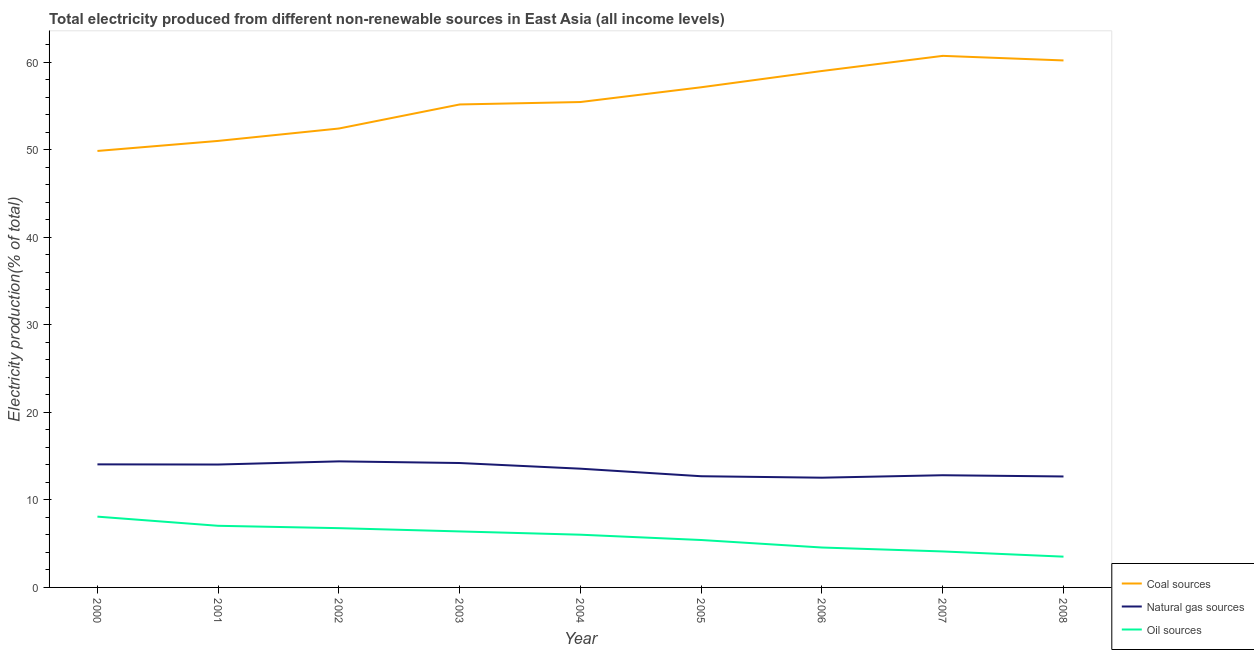Is the number of lines equal to the number of legend labels?
Keep it short and to the point. Yes. What is the percentage of electricity produced by coal in 2005?
Give a very brief answer. 57.15. Across all years, what is the maximum percentage of electricity produced by oil sources?
Your response must be concise. 8.09. Across all years, what is the minimum percentage of electricity produced by coal?
Give a very brief answer. 49.87. In which year was the percentage of electricity produced by oil sources maximum?
Offer a terse response. 2000. What is the total percentage of electricity produced by natural gas in the graph?
Offer a very short reply. 121.03. What is the difference between the percentage of electricity produced by natural gas in 2001 and that in 2007?
Give a very brief answer. 1.22. What is the difference between the percentage of electricity produced by coal in 2005 and the percentage of electricity produced by oil sources in 2001?
Your answer should be compact. 50.11. What is the average percentage of electricity produced by oil sources per year?
Give a very brief answer. 5.77. In the year 2004, what is the difference between the percentage of electricity produced by coal and percentage of electricity produced by natural gas?
Make the answer very short. 41.89. In how many years, is the percentage of electricity produced by natural gas greater than 58 %?
Offer a terse response. 0. What is the ratio of the percentage of electricity produced by coal in 2002 to that in 2008?
Offer a very short reply. 0.87. Is the percentage of electricity produced by oil sources in 2005 less than that in 2007?
Provide a succinct answer. No. What is the difference between the highest and the second highest percentage of electricity produced by coal?
Your answer should be very brief. 0.52. What is the difference between the highest and the lowest percentage of electricity produced by oil sources?
Your answer should be very brief. 4.57. Is the sum of the percentage of electricity produced by oil sources in 2001 and 2005 greater than the maximum percentage of electricity produced by coal across all years?
Your answer should be compact. No. Is it the case that in every year, the sum of the percentage of electricity produced by coal and percentage of electricity produced by natural gas is greater than the percentage of electricity produced by oil sources?
Ensure brevity in your answer.  Yes. Does the percentage of electricity produced by oil sources monotonically increase over the years?
Your response must be concise. No. Is the percentage of electricity produced by oil sources strictly greater than the percentage of electricity produced by natural gas over the years?
Ensure brevity in your answer.  No. Is the percentage of electricity produced by natural gas strictly less than the percentage of electricity produced by oil sources over the years?
Keep it short and to the point. No. How many lines are there?
Ensure brevity in your answer.  3. Are the values on the major ticks of Y-axis written in scientific E-notation?
Provide a short and direct response. No. Where does the legend appear in the graph?
Keep it short and to the point. Bottom right. How many legend labels are there?
Offer a very short reply. 3. What is the title of the graph?
Keep it short and to the point. Total electricity produced from different non-renewable sources in East Asia (all income levels). Does "Labor Market" appear as one of the legend labels in the graph?
Provide a short and direct response. No. What is the Electricity production(% of total) in Coal sources in 2000?
Offer a very short reply. 49.87. What is the Electricity production(% of total) of Natural gas sources in 2000?
Offer a very short reply. 14.06. What is the Electricity production(% of total) of Oil sources in 2000?
Your answer should be very brief. 8.09. What is the Electricity production(% of total) of Coal sources in 2001?
Your response must be concise. 51.02. What is the Electricity production(% of total) of Natural gas sources in 2001?
Ensure brevity in your answer.  14.04. What is the Electricity production(% of total) of Oil sources in 2001?
Your answer should be compact. 7.04. What is the Electricity production(% of total) in Coal sources in 2002?
Give a very brief answer. 52.44. What is the Electricity production(% of total) in Natural gas sources in 2002?
Your response must be concise. 14.41. What is the Electricity production(% of total) in Oil sources in 2002?
Your answer should be very brief. 6.77. What is the Electricity production(% of total) in Coal sources in 2003?
Your answer should be very brief. 55.18. What is the Electricity production(% of total) of Natural gas sources in 2003?
Your answer should be very brief. 14.21. What is the Electricity production(% of total) of Oil sources in 2003?
Provide a succinct answer. 6.4. What is the Electricity production(% of total) of Coal sources in 2004?
Your response must be concise. 55.46. What is the Electricity production(% of total) of Natural gas sources in 2004?
Your answer should be compact. 13.57. What is the Electricity production(% of total) in Oil sources in 2004?
Offer a terse response. 6.02. What is the Electricity production(% of total) of Coal sources in 2005?
Your answer should be compact. 57.15. What is the Electricity production(% of total) of Natural gas sources in 2005?
Offer a terse response. 12.7. What is the Electricity production(% of total) in Oil sources in 2005?
Keep it short and to the point. 5.42. What is the Electricity production(% of total) in Coal sources in 2006?
Your response must be concise. 59.01. What is the Electricity production(% of total) in Natural gas sources in 2006?
Offer a terse response. 12.54. What is the Electricity production(% of total) in Oil sources in 2006?
Keep it short and to the point. 4.56. What is the Electricity production(% of total) of Coal sources in 2007?
Give a very brief answer. 60.74. What is the Electricity production(% of total) in Natural gas sources in 2007?
Your response must be concise. 12.82. What is the Electricity production(% of total) of Oil sources in 2007?
Ensure brevity in your answer.  4.11. What is the Electricity production(% of total) in Coal sources in 2008?
Your response must be concise. 60.21. What is the Electricity production(% of total) in Natural gas sources in 2008?
Ensure brevity in your answer.  12.68. What is the Electricity production(% of total) in Oil sources in 2008?
Ensure brevity in your answer.  3.52. Across all years, what is the maximum Electricity production(% of total) in Coal sources?
Your answer should be very brief. 60.74. Across all years, what is the maximum Electricity production(% of total) of Natural gas sources?
Keep it short and to the point. 14.41. Across all years, what is the maximum Electricity production(% of total) of Oil sources?
Give a very brief answer. 8.09. Across all years, what is the minimum Electricity production(% of total) of Coal sources?
Your response must be concise. 49.87. Across all years, what is the minimum Electricity production(% of total) in Natural gas sources?
Make the answer very short. 12.54. Across all years, what is the minimum Electricity production(% of total) of Oil sources?
Provide a short and direct response. 3.52. What is the total Electricity production(% of total) of Coal sources in the graph?
Provide a succinct answer. 501.08. What is the total Electricity production(% of total) in Natural gas sources in the graph?
Make the answer very short. 121.03. What is the total Electricity production(% of total) of Oil sources in the graph?
Provide a short and direct response. 51.93. What is the difference between the Electricity production(% of total) in Coal sources in 2000 and that in 2001?
Provide a short and direct response. -1.15. What is the difference between the Electricity production(% of total) of Natural gas sources in 2000 and that in 2001?
Provide a succinct answer. 0.02. What is the difference between the Electricity production(% of total) in Oil sources in 2000 and that in 2001?
Provide a short and direct response. 1.05. What is the difference between the Electricity production(% of total) of Coal sources in 2000 and that in 2002?
Provide a short and direct response. -2.56. What is the difference between the Electricity production(% of total) in Natural gas sources in 2000 and that in 2002?
Provide a succinct answer. -0.34. What is the difference between the Electricity production(% of total) of Oil sources in 2000 and that in 2002?
Offer a terse response. 1.32. What is the difference between the Electricity production(% of total) of Coal sources in 2000 and that in 2003?
Keep it short and to the point. -5.31. What is the difference between the Electricity production(% of total) of Natural gas sources in 2000 and that in 2003?
Give a very brief answer. -0.15. What is the difference between the Electricity production(% of total) of Oil sources in 2000 and that in 2003?
Offer a terse response. 1.69. What is the difference between the Electricity production(% of total) of Coal sources in 2000 and that in 2004?
Make the answer very short. -5.59. What is the difference between the Electricity production(% of total) of Natural gas sources in 2000 and that in 2004?
Offer a terse response. 0.49. What is the difference between the Electricity production(% of total) in Oil sources in 2000 and that in 2004?
Your answer should be very brief. 2.06. What is the difference between the Electricity production(% of total) in Coal sources in 2000 and that in 2005?
Provide a short and direct response. -7.28. What is the difference between the Electricity production(% of total) in Natural gas sources in 2000 and that in 2005?
Provide a succinct answer. 1.36. What is the difference between the Electricity production(% of total) in Oil sources in 2000 and that in 2005?
Keep it short and to the point. 2.67. What is the difference between the Electricity production(% of total) of Coal sources in 2000 and that in 2006?
Give a very brief answer. -9.14. What is the difference between the Electricity production(% of total) of Natural gas sources in 2000 and that in 2006?
Offer a terse response. 1.52. What is the difference between the Electricity production(% of total) in Oil sources in 2000 and that in 2006?
Your response must be concise. 3.53. What is the difference between the Electricity production(% of total) in Coal sources in 2000 and that in 2007?
Your answer should be compact. -10.86. What is the difference between the Electricity production(% of total) of Natural gas sources in 2000 and that in 2007?
Give a very brief answer. 1.24. What is the difference between the Electricity production(% of total) of Oil sources in 2000 and that in 2007?
Offer a terse response. 3.97. What is the difference between the Electricity production(% of total) in Coal sources in 2000 and that in 2008?
Keep it short and to the point. -10.34. What is the difference between the Electricity production(% of total) in Natural gas sources in 2000 and that in 2008?
Make the answer very short. 1.38. What is the difference between the Electricity production(% of total) in Oil sources in 2000 and that in 2008?
Make the answer very short. 4.57. What is the difference between the Electricity production(% of total) in Coal sources in 2001 and that in 2002?
Provide a succinct answer. -1.42. What is the difference between the Electricity production(% of total) of Natural gas sources in 2001 and that in 2002?
Offer a terse response. -0.36. What is the difference between the Electricity production(% of total) of Oil sources in 2001 and that in 2002?
Keep it short and to the point. 0.27. What is the difference between the Electricity production(% of total) of Coal sources in 2001 and that in 2003?
Keep it short and to the point. -4.16. What is the difference between the Electricity production(% of total) of Natural gas sources in 2001 and that in 2003?
Provide a succinct answer. -0.17. What is the difference between the Electricity production(% of total) in Oil sources in 2001 and that in 2003?
Provide a succinct answer. 0.64. What is the difference between the Electricity production(% of total) in Coal sources in 2001 and that in 2004?
Provide a succinct answer. -4.44. What is the difference between the Electricity production(% of total) in Natural gas sources in 2001 and that in 2004?
Offer a very short reply. 0.47. What is the difference between the Electricity production(% of total) of Oil sources in 2001 and that in 2004?
Your response must be concise. 1.02. What is the difference between the Electricity production(% of total) of Coal sources in 2001 and that in 2005?
Make the answer very short. -6.13. What is the difference between the Electricity production(% of total) of Natural gas sources in 2001 and that in 2005?
Your answer should be very brief. 1.34. What is the difference between the Electricity production(% of total) in Oil sources in 2001 and that in 2005?
Make the answer very short. 1.62. What is the difference between the Electricity production(% of total) of Coal sources in 2001 and that in 2006?
Ensure brevity in your answer.  -7.99. What is the difference between the Electricity production(% of total) of Natural gas sources in 2001 and that in 2006?
Offer a very short reply. 1.5. What is the difference between the Electricity production(% of total) of Oil sources in 2001 and that in 2006?
Your answer should be very brief. 2.48. What is the difference between the Electricity production(% of total) in Coal sources in 2001 and that in 2007?
Offer a very short reply. -9.72. What is the difference between the Electricity production(% of total) of Natural gas sources in 2001 and that in 2007?
Your answer should be compact. 1.22. What is the difference between the Electricity production(% of total) in Oil sources in 2001 and that in 2007?
Make the answer very short. 2.93. What is the difference between the Electricity production(% of total) in Coal sources in 2001 and that in 2008?
Your answer should be compact. -9.19. What is the difference between the Electricity production(% of total) of Natural gas sources in 2001 and that in 2008?
Ensure brevity in your answer.  1.36. What is the difference between the Electricity production(% of total) of Oil sources in 2001 and that in 2008?
Your answer should be compact. 3.52. What is the difference between the Electricity production(% of total) in Coal sources in 2002 and that in 2003?
Your answer should be compact. -2.75. What is the difference between the Electricity production(% of total) of Natural gas sources in 2002 and that in 2003?
Your answer should be very brief. 0.19. What is the difference between the Electricity production(% of total) in Oil sources in 2002 and that in 2003?
Give a very brief answer. 0.37. What is the difference between the Electricity production(% of total) in Coal sources in 2002 and that in 2004?
Your answer should be very brief. -3.03. What is the difference between the Electricity production(% of total) in Natural gas sources in 2002 and that in 2004?
Ensure brevity in your answer.  0.84. What is the difference between the Electricity production(% of total) in Oil sources in 2002 and that in 2004?
Your answer should be very brief. 0.75. What is the difference between the Electricity production(% of total) of Coal sources in 2002 and that in 2005?
Keep it short and to the point. -4.71. What is the difference between the Electricity production(% of total) in Natural gas sources in 2002 and that in 2005?
Keep it short and to the point. 1.7. What is the difference between the Electricity production(% of total) of Oil sources in 2002 and that in 2005?
Make the answer very short. 1.35. What is the difference between the Electricity production(% of total) of Coal sources in 2002 and that in 2006?
Provide a succinct answer. -6.57. What is the difference between the Electricity production(% of total) in Natural gas sources in 2002 and that in 2006?
Your answer should be compact. 1.87. What is the difference between the Electricity production(% of total) of Oil sources in 2002 and that in 2006?
Your answer should be compact. 2.21. What is the difference between the Electricity production(% of total) of Coal sources in 2002 and that in 2007?
Provide a succinct answer. -8.3. What is the difference between the Electricity production(% of total) of Natural gas sources in 2002 and that in 2007?
Keep it short and to the point. 1.59. What is the difference between the Electricity production(% of total) in Oil sources in 2002 and that in 2007?
Provide a succinct answer. 2.66. What is the difference between the Electricity production(% of total) of Coal sources in 2002 and that in 2008?
Make the answer very short. -7.78. What is the difference between the Electricity production(% of total) of Natural gas sources in 2002 and that in 2008?
Provide a short and direct response. 1.73. What is the difference between the Electricity production(% of total) of Oil sources in 2002 and that in 2008?
Your answer should be compact. 3.26. What is the difference between the Electricity production(% of total) in Coal sources in 2003 and that in 2004?
Offer a very short reply. -0.28. What is the difference between the Electricity production(% of total) of Natural gas sources in 2003 and that in 2004?
Offer a very short reply. 0.65. What is the difference between the Electricity production(% of total) in Oil sources in 2003 and that in 2004?
Provide a short and direct response. 0.37. What is the difference between the Electricity production(% of total) of Coal sources in 2003 and that in 2005?
Give a very brief answer. -1.97. What is the difference between the Electricity production(% of total) of Natural gas sources in 2003 and that in 2005?
Keep it short and to the point. 1.51. What is the difference between the Electricity production(% of total) of Oil sources in 2003 and that in 2005?
Your answer should be compact. 0.98. What is the difference between the Electricity production(% of total) of Coal sources in 2003 and that in 2006?
Keep it short and to the point. -3.82. What is the difference between the Electricity production(% of total) of Natural gas sources in 2003 and that in 2006?
Keep it short and to the point. 1.67. What is the difference between the Electricity production(% of total) in Oil sources in 2003 and that in 2006?
Give a very brief answer. 1.84. What is the difference between the Electricity production(% of total) of Coal sources in 2003 and that in 2007?
Offer a very short reply. -5.55. What is the difference between the Electricity production(% of total) in Natural gas sources in 2003 and that in 2007?
Provide a short and direct response. 1.39. What is the difference between the Electricity production(% of total) in Oil sources in 2003 and that in 2007?
Offer a very short reply. 2.29. What is the difference between the Electricity production(% of total) of Coal sources in 2003 and that in 2008?
Give a very brief answer. -5.03. What is the difference between the Electricity production(% of total) in Natural gas sources in 2003 and that in 2008?
Your response must be concise. 1.54. What is the difference between the Electricity production(% of total) of Oil sources in 2003 and that in 2008?
Provide a short and direct response. 2.88. What is the difference between the Electricity production(% of total) in Coal sources in 2004 and that in 2005?
Provide a short and direct response. -1.69. What is the difference between the Electricity production(% of total) in Natural gas sources in 2004 and that in 2005?
Provide a succinct answer. 0.86. What is the difference between the Electricity production(% of total) in Oil sources in 2004 and that in 2005?
Your response must be concise. 0.61. What is the difference between the Electricity production(% of total) of Coal sources in 2004 and that in 2006?
Ensure brevity in your answer.  -3.55. What is the difference between the Electricity production(% of total) of Natural gas sources in 2004 and that in 2006?
Provide a succinct answer. 1.03. What is the difference between the Electricity production(% of total) of Oil sources in 2004 and that in 2006?
Your answer should be compact. 1.46. What is the difference between the Electricity production(% of total) of Coal sources in 2004 and that in 2007?
Your answer should be compact. -5.27. What is the difference between the Electricity production(% of total) of Natural gas sources in 2004 and that in 2007?
Give a very brief answer. 0.75. What is the difference between the Electricity production(% of total) in Oil sources in 2004 and that in 2007?
Your answer should be very brief. 1.91. What is the difference between the Electricity production(% of total) in Coal sources in 2004 and that in 2008?
Offer a terse response. -4.75. What is the difference between the Electricity production(% of total) in Natural gas sources in 2004 and that in 2008?
Give a very brief answer. 0.89. What is the difference between the Electricity production(% of total) of Oil sources in 2004 and that in 2008?
Ensure brevity in your answer.  2.51. What is the difference between the Electricity production(% of total) in Coal sources in 2005 and that in 2006?
Give a very brief answer. -1.86. What is the difference between the Electricity production(% of total) of Natural gas sources in 2005 and that in 2006?
Ensure brevity in your answer.  0.17. What is the difference between the Electricity production(% of total) of Oil sources in 2005 and that in 2006?
Your answer should be compact. 0.86. What is the difference between the Electricity production(% of total) in Coal sources in 2005 and that in 2007?
Your answer should be compact. -3.59. What is the difference between the Electricity production(% of total) of Natural gas sources in 2005 and that in 2007?
Your response must be concise. -0.12. What is the difference between the Electricity production(% of total) in Oil sources in 2005 and that in 2007?
Your answer should be compact. 1.31. What is the difference between the Electricity production(% of total) in Coal sources in 2005 and that in 2008?
Provide a succinct answer. -3.06. What is the difference between the Electricity production(% of total) in Natural gas sources in 2005 and that in 2008?
Your answer should be very brief. 0.03. What is the difference between the Electricity production(% of total) in Oil sources in 2005 and that in 2008?
Your response must be concise. 1.9. What is the difference between the Electricity production(% of total) of Coal sources in 2006 and that in 2007?
Ensure brevity in your answer.  -1.73. What is the difference between the Electricity production(% of total) of Natural gas sources in 2006 and that in 2007?
Keep it short and to the point. -0.28. What is the difference between the Electricity production(% of total) of Oil sources in 2006 and that in 2007?
Your response must be concise. 0.45. What is the difference between the Electricity production(% of total) in Coal sources in 2006 and that in 2008?
Ensure brevity in your answer.  -1.2. What is the difference between the Electricity production(% of total) of Natural gas sources in 2006 and that in 2008?
Offer a terse response. -0.14. What is the difference between the Electricity production(% of total) of Oil sources in 2006 and that in 2008?
Your answer should be compact. 1.04. What is the difference between the Electricity production(% of total) of Coal sources in 2007 and that in 2008?
Offer a very short reply. 0.52. What is the difference between the Electricity production(% of total) of Natural gas sources in 2007 and that in 2008?
Offer a very short reply. 0.14. What is the difference between the Electricity production(% of total) of Oil sources in 2007 and that in 2008?
Offer a very short reply. 0.6. What is the difference between the Electricity production(% of total) of Coal sources in 2000 and the Electricity production(% of total) of Natural gas sources in 2001?
Offer a terse response. 35.83. What is the difference between the Electricity production(% of total) of Coal sources in 2000 and the Electricity production(% of total) of Oil sources in 2001?
Provide a succinct answer. 42.83. What is the difference between the Electricity production(% of total) of Natural gas sources in 2000 and the Electricity production(% of total) of Oil sources in 2001?
Make the answer very short. 7.02. What is the difference between the Electricity production(% of total) of Coal sources in 2000 and the Electricity production(% of total) of Natural gas sources in 2002?
Your answer should be compact. 35.47. What is the difference between the Electricity production(% of total) in Coal sources in 2000 and the Electricity production(% of total) in Oil sources in 2002?
Provide a succinct answer. 43.1. What is the difference between the Electricity production(% of total) in Natural gas sources in 2000 and the Electricity production(% of total) in Oil sources in 2002?
Provide a succinct answer. 7.29. What is the difference between the Electricity production(% of total) of Coal sources in 2000 and the Electricity production(% of total) of Natural gas sources in 2003?
Keep it short and to the point. 35.66. What is the difference between the Electricity production(% of total) of Coal sources in 2000 and the Electricity production(% of total) of Oil sources in 2003?
Ensure brevity in your answer.  43.47. What is the difference between the Electricity production(% of total) in Natural gas sources in 2000 and the Electricity production(% of total) in Oil sources in 2003?
Your answer should be very brief. 7.66. What is the difference between the Electricity production(% of total) of Coal sources in 2000 and the Electricity production(% of total) of Natural gas sources in 2004?
Keep it short and to the point. 36.3. What is the difference between the Electricity production(% of total) of Coal sources in 2000 and the Electricity production(% of total) of Oil sources in 2004?
Keep it short and to the point. 43.85. What is the difference between the Electricity production(% of total) of Natural gas sources in 2000 and the Electricity production(% of total) of Oil sources in 2004?
Offer a terse response. 8.04. What is the difference between the Electricity production(% of total) in Coal sources in 2000 and the Electricity production(% of total) in Natural gas sources in 2005?
Offer a terse response. 37.17. What is the difference between the Electricity production(% of total) of Coal sources in 2000 and the Electricity production(% of total) of Oil sources in 2005?
Your answer should be compact. 44.45. What is the difference between the Electricity production(% of total) of Natural gas sources in 2000 and the Electricity production(% of total) of Oil sources in 2005?
Your answer should be very brief. 8.64. What is the difference between the Electricity production(% of total) in Coal sources in 2000 and the Electricity production(% of total) in Natural gas sources in 2006?
Make the answer very short. 37.33. What is the difference between the Electricity production(% of total) in Coal sources in 2000 and the Electricity production(% of total) in Oil sources in 2006?
Provide a short and direct response. 45.31. What is the difference between the Electricity production(% of total) in Natural gas sources in 2000 and the Electricity production(% of total) in Oil sources in 2006?
Your response must be concise. 9.5. What is the difference between the Electricity production(% of total) in Coal sources in 2000 and the Electricity production(% of total) in Natural gas sources in 2007?
Your answer should be compact. 37.05. What is the difference between the Electricity production(% of total) of Coal sources in 2000 and the Electricity production(% of total) of Oil sources in 2007?
Your response must be concise. 45.76. What is the difference between the Electricity production(% of total) of Natural gas sources in 2000 and the Electricity production(% of total) of Oil sources in 2007?
Your answer should be compact. 9.95. What is the difference between the Electricity production(% of total) of Coal sources in 2000 and the Electricity production(% of total) of Natural gas sources in 2008?
Keep it short and to the point. 37.19. What is the difference between the Electricity production(% of total) in Coal sources in 2000 and the Electricity production(% of total) in Oil sources in 2008?
Keep it short and to the point. 46.35. What is the difference between the Electricity production(% of total) of Natural gas sources in 2000 and the Electricity production(% of total) of Oil sources in 2008?
Offer a very short reply. 10.54. What is the difference between the Electricity production(% of total) in Coal sources in 2001 and the Electricity production(% of total) in Natural gas sources in 2002?
Offer a very short reply. 36.61. What is the difference between the Electricity production(% of total) of Coal sources in 2001 and the Electricity production(% of total) of Oil sources in 2002?
Provide a short and direct response. 44.25. What is the difference between the Electricity production(% of total) in Natural gas sources in 2001 and the Electricity production(% of total) in Oil sources in 2002?
Offer a very short reply. 7.27. What is the difference between the Electricity production(% of total) of Coal sources in 2001 and the Electricity production(% of total) of Natural gas sources in 2003?
Provide a succinct answer. 36.81. What is the difference between the Electricity production(% of total) of Coal sources in 2001 and the Electricity production(% of total) of Oil sources in 2003?
Keep it short and to the point. 44.62. What is the difference between the Electricity production(% of total) of Natural gas sources in 2001 and the Electricity production(% of total) of Oil sources in 2003?
Make the answer very short. 7.64. What is the difference between the Electricity production(% of total) of Coal sources in 2001 and the Electricity production(% of total) of Natural gas sources in 2004?
Provide a succinct answer. 37.45. What is the difference between the Electricity production(% of total) in Coal sources in 2001 and the Electricity production(% of total) in Oil sources in 2004?
Offer a terse response. 45. What is the difference between the Electricity production(% of total) of Natural gas sources in 2001 and the Electricity production(% of total) of Oil sources in 2004?
Make the answer very short. 8.02. What is the difference between the Electricity production(% of total) of Coal sources in 2001 and the Electricity production(% of total) of Natural gas sources in 2005?
Your response must be concise. 38.32. What is the difference between the Electricity production(% of total) of Coal sources in 2001 and the Electricity production(% of total) of Oil sources in 2005?
Offer a terse response. 45.6. What is the difference between the Electricity production(% of total) in Natural gas sources in 2001 and the Electricity production(% of total) in Oil sources in 2005?
Provide a short and direct response. 8.62. What is the difference between the Electricity production(% of total) in Coal sources in 2001 and the Electricity production(% of total) in Natural gas sources in 2006?
Ensure brevity in your answer.  38.48. What is the difference between the Electricity production(% of total) in Coal sources in 2001 and the Electricity production(% of total) in Oil sources in 2006?
Give a very brief answer. 46.46. What is the difference between the Electricity production(% of total) in Natural gas sources in 2001 and the Electricity production(% of total) in Oil sources in 2006?
Your response must be concise. 9.48. What is the difference between the Electricity production(% of total) of Coal sources in 2001 and the Electricity production(% of total) of Natural gas sources in 2007?
Make the answer very short. 38.2. What is the difference between the Electricity production(% of total) of Coal sources in 2001 and the Electricity production(% of total) of Oil sources in 2007?
Offer a terse response. 46.91. What is the difference between the Electricity production(% of total) in Natural gas sources in 2001 and the Electricity production(% of total) in Oil sources in 2007?
Give a very brief answer. 9.93. What is the difference between the Electricity production(% of total) of Coal sources in 2001 and the Electricity production(% of total) of Natural gas sources in 2008?
Your answer should be compact. 38.34. What is the difference between the Electricity production(% of total) in Coal sources in 2001 and the Electricity production(% of total) in Oil sources in 2008?
Make the answer very short. 47.5. What is the difference between the Electricity production(% of total) of Natural gas sources in 2001 and the Electricity production(% of total) of Oil sources in 2008?
Give a very brief answer. 10.52. What is the difference between the Electricity production(% of total) in Coal sources in 2002 and the Electricity production(% of total) in Natural gas sources in 2003?
Provide a succinct answer. 38.22. What is the difference between the Electricity production(% of total) in Coal sources in 2002 and the Electricity production(% of total) in Oil sources in 2003?
Your answer should be compact. 46.04. What is the difference between the Electricity production(% of total) of Natural gas sources in 2002 and the Electricity production(% of total) of Oil sources in 2003?
Your response must be concise. 8.01. What is the difference between the Electricity production(% of total) in Coal sources in 2002 and the Electricity production(% of total) in Natural gas sources in 2004?
Keep it short and to the point. 38.87. What is the difference between the Electricity production(% of total) in Coal sources in 2002 and the Electricity production(% of total) in Oil sources in 2004?
Your response must be concise. 46.41. What is the difference between the Electricity production(% of total) of Natural gas sources in 2002 and the Electricity production(% of total) of Oil sources in 2004?
Keep it short and to the point. 8.38. What is the difference between the Electricity production(% of total) in Coal sources in 2002 and the Electricity production(% of total) in Natural gas sources in 2005?
Provide a short and direct response. 39.73. What is the difference between the Electricity production(% of total) of Coal sources in 2002 and the Electricity production(% of total) of Oil sources in 2005?
Your response must be concise. 47.02. What is the difference between the Electricity production(% of total) in Natural gas sources in 2002 and the Electricity production(% of total) in Oil sources in 2005?
Your answer should be compact. 8.99. What is the difference between the Electricity production(% of total) of Coal sources in 2002 and the Electricity production(% of total) of Natural gas sources in 2006?
Ensure brevity in your answer.  39.9. What is the difference between the Electricity production(% of total) in Coal sources in 2002 and the Electricity production(% of total) in Oil sources in 2006?
Give a very brief answer. 47.88. What is the difference between the Electricity production(% of total) of Natural gas sources in 2002 and the Electricity production(% of total) of Oil sources in 2006?
Your response must be concise. 9.84. What is the difference between the Electricity production(% of total) of Coal sources in 2002 and the Electricity production(% of total) of Natural gas sources in 2007?
Offer a terse response. 39.62. What is the difference between the Electricity production(% of total) of Coal sources in 2002 and the Electricity production(% of total) of Oil sources in 2007?
Offer a terse response. 48.32. What is the difference between the Electricity production(% of total) of Natural gas sources in 2002 and the Electricity production(% of total) of Oil sources in 2007?
Make the answer very short. 10.29. What is the difference between the Electricity production(% of total) in Coal sources in 2002 and the Electricity production(% of total) in Natural gas sources in 2008?
Make the answer very short. 39.76. What is the difference between the Electricity production(% of total) in Coal sources in 2002 and the Electricity production(% of total) in Oil sources in 2008?
Provide a succinct answer. 48.92. What is the difference between the Electricity production(% of total) of Natural gas sources in 2002 and the Electricity production(% of total) of Oil sources in 2008?
Your answer should be compact. 10.89. What is the difference between the Electricity production(% of total) of Coal sources in 2003 and the Electricity production(% of total) of Natural gas sources in 2004?
Make the answer very short. 41.62. What is the difference between the Electricity production(% of total) in Coal sources in 2003 and the Electricity production(% of total) in Oil sources in 2004?
Offer a very short reply. 49.16. What is the difference between the Electricity production(% of total) in Natural gas sources in 2003 and the Electricity production(% of total) in Oil sources in 2004?
Provide a short and direct response. 8.19. What is the difference between the Electricity production(% of total) in Coal sources in 2003 and the Electricity production(% of total) in Natural gas sources in 2005?
Your answer should be compact. 42.48. What is the difference between the Electricity production(% of total) in Coal sources in 2003 and the Electricity production(% of total) in Oil sources in 2005?
Make the answer very short. 49.77. What is the difference between the Electricity production(% of total) in Natural gas sources in 2003 and the Electricity production(% of total) in Oil sources in 2005?
Offer a terse response. 8.8. What is the difference between the Electricity production(% of total) of Coal sources in 2003 and the Electricity production(% of total) of Natural gas sources in 2006?
Your answer should be compact. 42.64. What is the difference between the Electricity production(% of total) in Coal sources in 2003 and the Electricity production(% of total) in Oil sources in 2006?
Offer a very short reply. 50.62. What is the difference between the Electricity production(% of total) of Natural gas sources in 2003 and the Electricity production(% of total) of Oil sources in 2006?
Your answer should be compact. 9.65. What is the difference between the Electricity production(% of total) in Coal sources in 2003 and the Electricity production(% of total) in Natural gas sources in 2007?
Ensure brevity in your answer.  42.36. What is the difference between the Electricity production(% of total) of Coal sources in 2003 and the Electricity production(% of total) of Oil sources in 2007?
Your answer should be compact. 51.07. What is the difference between the Electricity production(% of total) in Natural gas sources in 2003 and the Electricity production(% of total) in Oil sources in 2007?
Your answer should be very brief. 10.1. What is the difference between the Electricity production(% of total) in Coal sources in 2003 and the Electricity production(% of total) in Natural gas sources in 2008?
Give a very brief answer. 42.51. What is the difference between the Electricity production(% of total) of Coal sources in 2003 and the Electricity production(% of total) of Oil sources in 2008?
Your response must be concise. 51.67. What is the difference between the Electricity production(% of total) of Natural gas sources in 2003 and the Electricity production(% of total) of Oil sources in 2008?
Offer a terse response. 10.7. What is the difference between the Electricity production(% of total) of Coal sources in 2004 and the Electricity production(% of total) of Natural gas sources in 2005?
Provide a short and direct response. 42.76. What is the difference between the Electricity production(% of total) in Coal sources in 2004 and the Electricity production(% of total) in Oil sources in 2005?
Offer a very short reply. 50.04. What is the difference between the Electricity production(% of total) of Natural gas sources in 2004 and the Electricity production(% of total) of Oil sources in 2005?
Ensure brevity in your answer.  8.15. What is the difference between the Electricity production(% of total) of Coal sources in 2004 and the Electricity production(% of total) of Natural gas sources in 2006?
Offer a very short reply. 42.92. What is the difference between the Electricity production(% of total) of Coal sources in 2004 and the Electricity production(% of total) of Oil sources in 2006?
Your answer should be compact. 50.9. What is the difference between the Electricity production(% of total) in Natural gas sources in 2004 and the Electricity production(% of total) in Oil sources in 2006?
Provide a short and direct response. 9.01. What is the difference between the Electricity production(% of total) of Coal sources in 2004 and the Electricity production(% of total) of Natural gas sources in 2007?
Keep it short and to the point. 42.64. What is the difference between the Electricity production(% of total) of Coal sources in 2004 and the Electricity production(% of total) of Oil sources in 2007?
Keep it short and to the point. 51.35. What is the difference between the Electricity production(% of total) of Natural gas sources in 2004 and the Electricity production(% of total) of Oil sources in 2007?
Your answer should be very brief. 9.45. What is the difference between the Electricity production(% of total) of Coal sources in 2004 and the Electricity production(% of total) of Natural gas sources in 2008?
Your answer should be very brief. 42.78. What is the difference between the Electricity production(% of total) of Coal sources in 2004 and the Electricity production(% of total) of Oil sources in 2008?
Provide a short and direct response. 51.95. What is the difference between the Electricity production(% of total) of Natural gas sources in 2004 and the Electricity production(% of total) of Oil sources in 2008?
Provide a short and direct response. 10.05. What is the difference between the Electricity production(% of total) of Coal sources in 2005 and the Electricity production(% of total) of Natural gas sources in 2006?
Provide a short and direct response. 44.61. What is the difference between the Electricity production(% of total) of Coal sources in 2005 and the Electricity production(% of total) of Oil sources in 2006?
Make the answer very short. 52.59. What is the difference between the Electricity production(% of total) of Natural gas sources in 2005 and the Electricity production(% of total) of Oil sources in 2006?
Make the answer very short. 8.14. What is the difference between the Electricity production(% of total) of Coal sources in 2005 and the Electricity production(% of total) of Natural gas sources in 2007?
Make the answer very short. 44.33. What is the difference between the Electricity production(% of total) of Coal sources in 2005 and the Electricity production(% of total) of Oil sources in 2007?
Your answer should be compact. 53.04. What is the difference between the Electricity production(% of total) of Natural gas sources in 2005 and the Electricity production(% of total) of Oil sources in 2007?
Offer a terse response. 8.59. What is the difference between the Electricity production(% of total) of Coal sources in 2005 and the Electricity production(% of total) of Natural gas sources in 2008?
Provide a short and direct response. 44.47. What is the difference between the Electricity production(% of total) of Coal sources in 2005 and the Electricity production(% of total) of Oil sources in 2008?
Give a very brief answer. 53.63. What is the difference between the Electricity production(% of total) of Natural gas sources in 2005 and the Electricity production(% of total) of Oil sources in 2008?
Your answer should be compact. 9.19. What is the difference between the Electricity production(% of total) in Coal sources in 2006 and the Electricity production(% of total) in Natural gas sources in 2007?
Your response must be concise. 46.19. What is the difference between the Electricity production(% of total) of Coal sources in 2006 and the Electricity production(% of total) of Oil sources in 2007?
Provide a short and direct response. 54.9. What is the difference between the Electricity production(% of total) in Natural gas sources in 2006 and the Electricity production(% of total) in Oil sources in 2007?
Your answer should be compact. 8.43. What is the difference between the Electricity production(% of total) of Coal sources in 2006 and the Electricity production(% of total) of Natural gas sources in 2008?
Keep it short and to the point. 46.33. What is the difference between the Electricity production(% of total) of Coal sources in 2006 and the Electricity production(% of total) of Oil sources in 2008?
Offer a terse response. 55.49. What is the difference between the Electricity production(% of total) of Natural gas sources in 2006 and the Electricity production(% of total) of Oil sources in 2008?
Offer a terse response. 9.02. What is the difference between the Electricity production(% of total) of Coal sources in 2007 and the Electricity production(% of total) of Natural gas sources in 2008?
Offer a very short reply. 48.06. What is the difference between the Electricity production(% of total) of Coal sources in 2007 and the Electricity production(% of total) of Oil sources in 2008?
Give a very brief answer. 57.22. What is the difference between the Electricity production(% of total) in Natural gas sources in 2007 and the Electricity production(% of total) in Oil sources in 2008?
Make the answer very short. 9.3. What is the average Electricity production(% of total) in Coal sources per year?
Provide a short and direct response. 55.68. What is the average Electricity production(% of total) in Natural gas sources per year?
Give a very brief answer. 13.45. What is the average Electricity production(% of total) in Oil sources per year?
Provide a succinct answer. 5.77. In the year 2000, what is the difference between the Electricity production(% of total) of Coal sources and Electricity production(% of total) of Natural gas sources?
Ensure brevity in your answer.  35.81. In the year 2000, what is the difference between the Electricity production(% of total) of Coal sources and Electricity production(% of total) of Oil sources?
Offer a very short reply. 41.78. In the year 2000, what is the difference between the Electricity production(% of total) of Natural gas sources and Electricity production(% of total) of Oil sources?
Provide a succinct answer. 5.97. In the year 2001, what is the difference between the Electricity production(% of total) of Coal sources and Electricity production(% of total) of Natural gas sources?
Ensure brevity in your answer.  36.98. In the year 2001, what is the difference between the Electricity production(% of total) in Coal sources and Electricity production(% of total) in Oil sources?
Offer a terse response. 43.98. In the year 2001, what is the difference between the Electricity production(% of total) of Natural gas sources and Electricity production(% of total) of Oil sources?
Your response must be concise. 7. In the year 2002, what is the difference between the Electricity production(% of total) in Coal sources and Electricity production(% of total) in Natural gas sources?
Make the answer very short. 38.03. In the year 2002, what is the difference between the Electricity production(% of total) in Coal sources and Electricity production(% of total) in Oil sources?
Your answer should be compact. 45.66. In the year 2002, what is the difference between the Electricity production(% of total) of Natural gas sources and Electricity production(% of total) of Oil sources?
Give a very brief answer. 7.63. In the year 2003, what is the difference between the Electricity production(% of total) of Coal sources and Electricity production(% of total) of Natural gas sources?
Give a very brief answer. 40.97. In the year 2003, what is the difference between the Electricity production(% of total) in Coal sources and Electricity production(% of total) in Oil sources?
Offer a very short reply. 48.79. In the year 2003, what is the difference between the Electricity production(% of total) in Natural gas sources and Electricity production(% of total) in Oil sources?
Keep it short and to the point. 7.82. In the year 2004, what is the difference between the Electricity production(% of total) of Coal sources and Electricity production(% of total) of Natural gas sources?
Offer a terse response. 41.89. In the year 2004, what is the difference between the Electricity production(% of total) of Coal sources and Electricity production(% of total) of Oil sources?
Your answer should be very brief. 49.44. In the year 2004, what is the difference between the Electricity production(% of total) of Natural gas sources and Electricity production(% of total) of Oil sources?
Your answer should be very brief. 7.54. In the year 2005, what is the difference between the Electricity production(% of total) of Coal sources and Electricity production(% of total) of Natural gas sources?
Provide a succinct answer. 44.44. In the year 2005, what is the difference between the Electricity production(% of total) of Coal sources and Electricity production(% of total) of Oil sources?
Offer a very short reply. 51.73. In the year 2005, what is the difference between the Electricity production(% of total) in Natural gas sources and Electricity production(% of total) in Oil sources?
Provide a short and direct response. 7.29. In the year 2006, what is the difference between the Electricity production(% of total) in Coal sources and Electricity production(% of total) in Natural gas sources?
Your answer should be very brief. 46.47. In the year 2006, what is the difference between the Electricity production(% of total) in Coal sources and Electricity production(% of total) in Oil sources?
Give a very brief answer. 54.45. In the year 2006, what is the difference between the Electricity production(% of total) in Natural gas sources and Electricity production(% of total) in Oil sources?
Provide a short and direct response. 7.98. In the year 2007, what is the difference between the Electricity production(% of total) of Coal sources and Electricity production(% of total) of Natural gas sources?
Keep it short and to the point. 47.92. In the year 2007, what is the difference between the Electricity production(% of total) of Coal sources and Electricity production(% of total) of Oil sources?
Offer a very short reply. 56.62. In the year 2007, what is the difference between the Electricity production(% of total) of Natural gas sources and Electricity production(% of total) of Oil sources?
Your answer should be very brief. 8.71. In the year 2008, what is the difference between the Electricity production(% of total) of Coal sources and Electricity production(% of total) of Natural gas sources?
Offer a very short reply. 47.54. In the year 2008, what is the difference between the Electricity production(% of total) in Coal sources and Electricity production(% of total) in Oil sources?
Offer a very short reply. 56.7. In the year 2008, what is the difference between the Electricity production(% of total) in Natural gas sources and Electricity production(% of total) in Oil sources?
Make the answer very short. 9.16. What is the ratio of the Electricity production(% of total) in Coal sources in 2000 to that in 2001?
Keep it short and to the point. 0.98. What is the ratio of the Electricity production(% of total) in Oil sources in 2000 to that in 2001?
Provide a short and direct response. 1.15. What is the ratio of the Electricity production(% of total) in Coal sources in 2000 to that in 2002?
Your response must be concise. 0.95. What is the ratio of the Electricity production(% of total) in Natural gas sources in 2000 to that in 2002?
Your answer should be very brief. 0.98. What is the ratio of the Electricity production(% of total) in Oil sources in 2000 to that in 2002?
Offer a terse response. 1.19. What is the ratio of the Electricity production(% of total) in Coal sources in 2000 to that in 2003?
Ensure brevity in your answer.  0.9. What is the ratio of the Electricity production(% of total) in Oil sources in 2000 to that in 2003?
Make the answer very short. 1.26. What is the ratio of the Electricity production(% of total) of Coal sources in 2000 to that in 2004?
Offer a terse response. 0.9. What is the ratio of the Electricity production(% of total) of Natural gas sources in 2000 to that in 2004?
Provide a short and direct response. 1.04. What is the ratio of the Electricity production(% of total) of Oil sources in 2000 to that in 2004?
Provide a succinct answer. 1.34. What is the ratio of the Electricity production(% of total) in Coal sources in 2000 to that in 2005?
Offer a very short reply. 0.87. What is the ratio of the Electricity production(% of total) of Natural gas sources in 2000 to that in 2005?
Offer a very short reply. 1.11. What is the ratio of the Electricity production(% of total) of Oil sources in 2000 to that in 2005?
Offer a terse response. 1.49. What is the ratio of the Electricity production(% of total) in Coal sources in 2000 to that in 2006?
Ensure brevity in your answer.  0.85. What is the ratio of the Electricity production(% of total) of Natural gas sources in 2000 to that in 2006?
Make the answer very short. 1.12. What is the ratio of the Electricity production(% of total) of Oil sources in 2000 to that in 2006?
Make the answer very short. 1.77. What is the ratio of the Electricity production(% of total) in Coal sources in 2000 to that in 2007?
Ensure brevity in your answer.  0.82. What is the ratio of the Electricity production(% of total) in Natural gas sources in 2000 to that in 2007?
Provide a short and direct response. 1.1. What is the ratio of the Electricity production(% of total) in Oil sources in 2000 to that in 2007?
Your answer should be compact. 1.97. What is the ratio of the Electricity production(% of total) in Coal sources in 2000 to that in 2008?
Make the answer very short. 0.83. What is the ratio of the Electricity production(% of total) in Natural gas sources in 2000 to that in 2008?
Ensure brevity in your answer.  1.11. What is the ratio of the Electricity production(% of total) in Oil sources in 2000 to that in 2008?
Offer a very short reply. 2.3. What is the ratio of the Electricity production(% of total) of Natural gas sources in 2001 to that in 2002?
Provide a short and direct response. 0.97. What is the ratio of the Electricity production(% of total) in Oil sources in 2001 to that in 2002?
Your response must be concise. 1.04. What is the ratio of the Electricity production(% of total) in Coal sources in 2001 to that in 2003?
Your answer should be very brief. 0.92. What is the ratio of the Electricity production(% of total) in Natural gas sources in 2001 to that in 2003?
Give a very brief answer. 0.99. What is the ratio of the Electricity production(% of total) of Oil sources in 2001 to that in 2003?
Offer a terse response. 1.1. What is the ratio of the Electricity production(% of total) of Coal sources in 2001 to that in 2004?
Offer a very short reply. 0.92. What is the ratio of the Electricity production(% of total) of Natural gas sources in 2001 to that in 2004?
Make the answer very short. 1.03. What is the ratio of the Electricity production(% of total) in Oil sources in 2001 to that in 2004?
Provide a succinct answer. 1.17. What is the ratio of the Electricity production(% of total) in Coal sources in 2001 to that in 2005?
Offer a very short reply. 0.89. What is the ratio of the Electricity production(% of total) in Natural gas sources in 2001 to that in 2005?
Give a very brief answer. 1.11. What is the ratio of the Electricity production(% of total) in Oil sources in 2001 to that in 2005?
Your answer should be compact. 1.3. What is the ratio of the Electricity production(% of total) in Coal sources in 2001 to that in 2006?
Make the answer very short. 0.86. What is the ratio of the Electricity production(% of total) of Natural gas sources in 2001 to that in 2006?
Your answer should be compact. 1.12. What is the ratio of the Electricity production(% of total) of Oil sources in 2001 to that in 2006?
Offer a terse response. 1.54. What is the ratio of the Electricity production(% of total) in Coal sources in 2001 to that in 2007?
Provide a succinct answer. 0.84. What is the ratio of the Electricity production(% of total) in Natural gas sources in 2001 to that in 2007?
Provide a succinct answer. 1.1. What is the ratio of the Electricity production(% of total) in Oil sources in 2001 to that in 2007?
Keep it short and to the point. 1.71. What is the ratio of the Electricity production(% of total) of Coal sources in 2001 to that in 2008?
Provide a short and direct response. 0.85. What is the ratio of the Electricity production(% of total) in Natural gas sources in 2001 to that in 2008?
Make the answer very short. 1.11. What is the ratio of the Electricity production(% of total) of Oil sources in 2001 to that in 2008?
Provide a short and direct response. 2. What is the ratio of the Electricity production(% of total) in Coal sources in 2002 to that in 2003?
Provide a succinct answer. 0.95. What is the ratio of the Electricity production(% of total) of Natural gas sources in 2002 to that in 2003?
Your answer should be very brief. 1.01. What is the ratio of the Electricity production(% of total) of Oil sources in 2002 to that in 2003?
Your answer should be compact. 1.06. What is the ratio of the Electricity production(% of total) of Coal sources in 2002 to that in 2004?
Offer a very short reply. 0.95. What is the ratio of the Electricity production(% of total) in Natural gas sources in 2002 to that in 2004?
Ensure brevity in your answer.  1.06. What is the ratio of the Electricity production(% of total) of Oil sources in 2002 to that in 2004?
Offer a very short reply. 1.12. What is the ratio of the Electricity production(% of total) in Coal sources in 2002 to that in 2005?
Give a very brief answer. 0.92. What is the ratio of the Electricity production(% of total) of Natural gas sources in 2002 to that in 2005?
Give a very brief answer. 1.13. What is the ratio of the Electricity production(% of total) of Oil sources in 2002 to that in 2005?
Keep it short and to the point. 1.25. What is the ratio of the Electricity production(% of total) of Coal sources in 2002 to that in 2006?
Keep it short and to the point. 0.89. What is the ratio of the Electricity production(% of total) of Natural gas sources in 2002 to that in 2006?
Provide a succinct answer. 1.15. What is the ratio of the Electricity production(% of total) in Oil sources in 2002 to that in 2006?
Keep it short and to the point. 1.49. What is the ratio of the Electricity production(% of total) of Coal sources in 2002 to that in 2007?
Your answer should be compact. 0.86. What is the ratio of the Electricity production(% of total) of Natural gas sources in 2002 to that in 2007?
Provide a short and direct response. 1.12. What is the ratio of the Electricity production(% of total) in Oil sources in 2002 to that in 2007?
Offer a very short reply. 1.65. What is the ratio of the Electricity production(% of total) of Coal sources in 2002 to that in 2008?
Give a very brief answer. 0.87. What is the ratio of the Electricity production(% of total) of Natural gas sources in 2002 to that in 2008?
Your response must be concise. 1.14. What is the ratio of the Electricity production(% of total) of Oil sources in 2002 to that in 2008?
Ensure brevity in your answer.  1.93. What is the ratio of the Electricity production(% of total) of Coal sources in 2003 to that in 2004?
Provide a short and direct response. 0.99. What is the ratio of the Electricity production(% of total) in Natural gas sources in 2003 to that in 2004?
Offer a very short reply. 1.05. What is the ratio of the Electricity production(% of total) in Oil sources in 2003 to that in 2004?
Offer a very short reply. 1.06. What is the ratio of the Electricity production(% of total) in Coal sources in 2003 to that in 2005?
Provide a succinct answer. 0.97. What is the ratio of the Electricity production(% of total) of Natural gas sources in 2003 to that in 2005?
Your response must be concise. 1.12. What is the ratio of the Electricity production(% of total) of Oil sources in 2003 to that in 2005?
Provide a short and direct response. 1.18. What is the ratio of the Electricity production(% of total) of Coal sources in 2003 to that in 2006?
Provide a short and direct response. 0.94. What is the ratio of the Electricity production(% of total) of Natural gas sources in 2003 to that in 2006?
Provide a short and direct response. 1.13. What is the ratio of the Electricity production(% of total) in Oil sources in 2003 to that in 2006?
Keep it short and to the point. 1.4. What is the ratio of the Electricity production(% of total) in Coal sources in 2003 to that in 2007?
Provide a succinct answer. 0.91. What is the ratio of the Electricity production(% of total) of Natural gas sources in 2003 to that in 2007?
Offer a terse response. 1.11. What is the ratio of the Electricity production(% of total) in Oil sources in 2003 to that in 2007?
Ensure brevity in your answer.  1.56. What is the ratio of the Electricity production(% of total) in Coal sources in 2003 to that in 2008?
Your answer should be very brief. 0.92. What is the ratio of the Electricity production(% of total) in Natural gas sources in 2003 to that in 2008?
Offer a terse response. 1.12. What is the ratio of the Electricity production(% of total) in Oil sources in 2003 to that in 2008?
Your answer should be very brief. 1.82. What is the ratio of the Electricity production(% of total) in Coal sources in 2004 to that in 2005?
Offer a very short reply. 0.97. What is the ratio of the Electricity production(% of total) of Natural gas sources in 2004 to that in 2005?
Offer a terse response. 1.07. What is the ratio of the Electricity production(% of total) in Oil sources in 2004 to that in 2005?
Offer a terse response. 1.11. What is the ratio of the Electricity production(% of total) of Coal sources in 2004 to that in 2006?
Your answer should be compact. 0.94. What is the ratio of the Electricity production(% of total) in Natural gas sources in 2004 to that in 2006?
Give a very brief answer. 1.08. What is the ratio of the Electricity production(% of total) in Oil sources in 2004 to that in 2006?
Provide a short and direct response. 1.32. What is the ratio of the Electricity production(% of total) of Coal sources in 2004 to that in 2007?
Ensure brevity in your answer.  0.91. What is the ratio of the Electricity production(% of total) of Natural gas sources in 2004 to that in 2007?
Make the answer very short. 1.06. What is the ratio of the Electricity production(% of total) in Oil sources in 2004 to that in 2007?
Ensure brevity in your answer.  1.46. What is the ratio of the Electricity production(% of total) of Coal sources in 2004 to that in 2008?
Your answer should be very brief. 0.92. What is the ratio of the Electricity production(% of total) in Natural gas sources in 2004 to that in 2008?
Make the answer very short. 1.07. What is the ratio of the Electricity production(% of total) in Oil sources in 2004 to that in 2008?
Keep it short and to the point. 1.71. What is the ratio of the Electricity production(% of total) in Coal sources in 2005 to that in 2006?
Provide a short and direct response. 0.97. What is the ratio of the Electricity production(% of total) of Natural gas sources in 2005 to that in 2006?
Ensure brevity in your answer.  1.01. What is the ratio of the Electricity production(% of total) of Oil sources in 2005 to that in 2006?
Provide a short and direct response. 1.19. What is the ratio of the Electricity production(% of total) of Coal sources in 2005 to that in 2007?
Offer a very short reply. 0.94. What is the ratio of the Electricity production(% of total) in Natural gas sources in 2005 to that in 2007?
Your answer should be very brief. 0.99. What is the ratio of the Electricity production(% of total) in Oil sources in 2005 to that in 2007?
Offer a very short reply. 1.32. What is the ratio of the Electricity production(% of total) in Coal sources in 2005 to that in 2008?
Your answer should be compact. 0.95. What is the ratio of the Electricity production(% of total) of Oil sources in 2005 to that in 2008?
Offer a terse response. 1.54. What is the ratio of the Electricity production(% of total) in Coal sources in 2006 to that in 2007?
Offer a terse response. 0.97. What is the ratio of the Electricity production(% of total) of Natural gas sources in 2006 to that in 2007?
Make the answer very short. 0.98. What is the ratio of the Electricity production(% of total) of Oil sources in 2006 to that in 2007?
Make the answer very short. 1.11. What is the ratio of the Electricity production(% of total) in Coal sources in 2006 to that in 2008?
Give a very brief answer. 0.98. What is the ratio of the Electricity production(% of total) in Natural gas sources in 2006 to that in 2008?
Make the answer very short. 0.99. What is the ratio of the Electricity production(% of total) in Oil sources in 2006 to that in 2008?
Provide a short and direct response. 1.3. What is the ratio of the Electricity production(% of total) in Coal sources in 2007 to that in 2008?
Make the answer very short. 1.01. What is the ratio of the Electricity production(% of total) in Natural gas sources in 2007 to that in 2008?
Provide a short and direct response. 1.01. What is the ratio of the Electricity production(% of total) in Oil sources in 2007 to that in 2008?
Keep it short and to the point. 1.17. What is the difference between the highest and the second highest Electricity production(% of total) of Coal sources?
Make the answer very short. 0.52. What is the difference between the highest and the second highest Electricity production(% of total) in Natural gas sources?
Your response must be concise. 0.19. What is the difference between the highest and the second highest Electricity production(% of total) in Oil sources?
Your response must be concise. 1.05. What is the difference between the highest and the lowest Electricity production(% of total) of Coal sources?
Offer a very short reply. 10.86. What is the difference between the highest and the lowest Electricity production(% of total) of Natural gas sources?
Make the answer very short. 1.87. What is the difference between the highest and the lowest Electricity production(% of total) in Oil sources?
Offer a terse response. 4.57. 